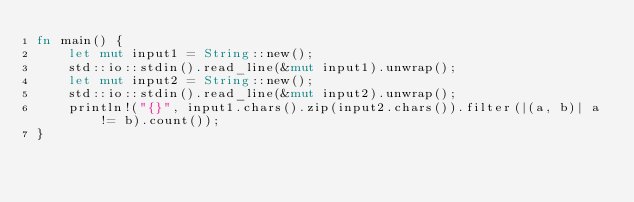Convert code to text. <code><loc_0><loc_0><loc_500><loc_500><_Rust_>fn main() {
    let mut input1 = String::new();
    std::io::stdin().read_line(&mut input1).unwrap();
    let mut input2 = String::new();
    std::io::stdin().read_line(&mut input2).unwrap();
    println!("{}", input1.chars().zip(input2.chars()).filter(|(a, b)| a != b).count());
}</code> 